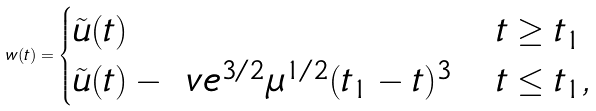<formula> <loc_0><loc_0><loc_500><loc_500>w ( t ) = \begin{cases} \tilde { u } ( t ) & t \geq t _ { 1 } \\ \tilde { u } ( t ) - \ v e ^ { 3 / 2 } \mu ^ { 1 / 2 } ( t _ { 1 } - t ) ^ { 3 } & t \leq t _ { 1 } , \end{cases}</formula> 